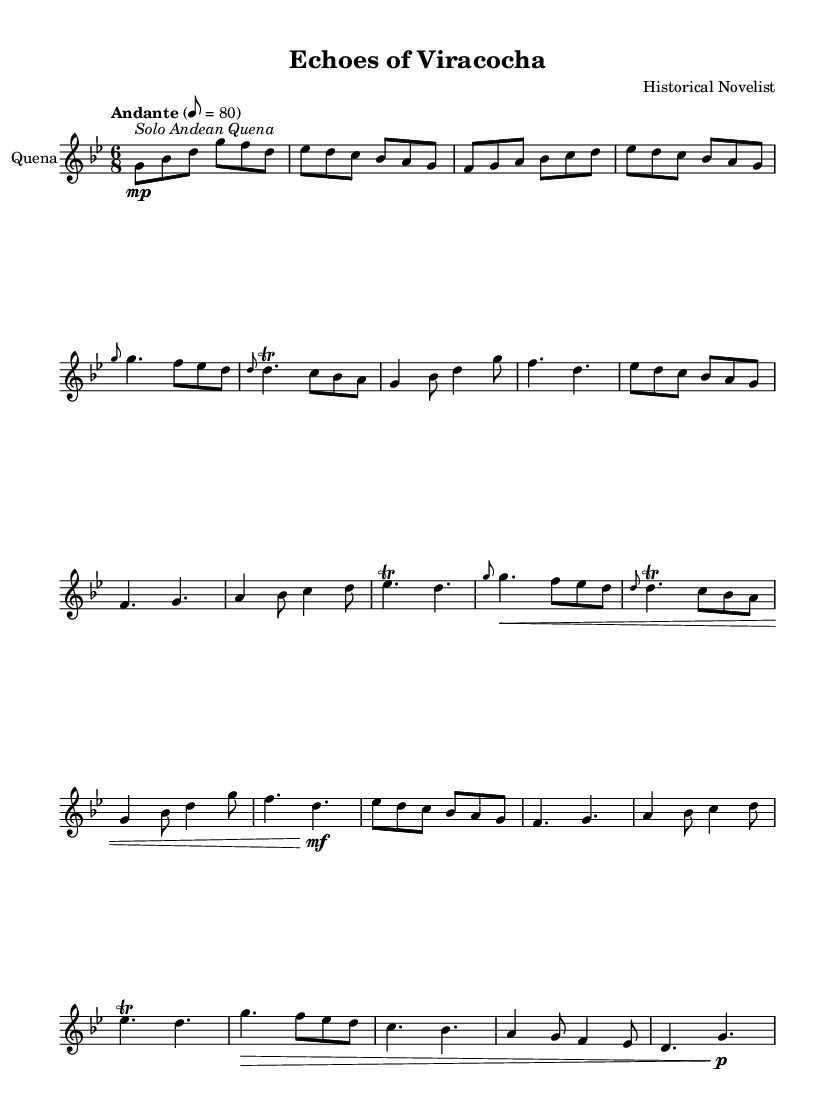What is the key signature of this music? The key signature is G minor, which is indicated by two flats (B-flat and E-flat). This can be determined by looking at the key signature at the beginning of the staff.
Answer: G minor What is the time signature of the piece? The time signature is 6/8, which is displayed at the beginning of the music. It indicates that there are six eighth notes per measure.
Answer: 6/8 What is the tempo marking of this piece? The tempo marking is "Andante", which suggests a moderate tempo. In the score, the tempo is indicated after the key and time signature, along with a metronome marking of 80 beats per minute.
Answer: Andante How many themes are present in the music? There are two distinct themes labeled as Theme A and Theme B, identifiable by their structure and melodic content. These themes are indicated in the score.
Answer: Two What is the dynamic marking for the first coda section? The dynamic marking for the first coda section is a crescendo followed by a piano marking on the last note. This indicates that the volume should increase and then soften.
Answer: Crescendo and piano What instrument is indicated in the score? The instrument indicated in the score is the Quena, which is mentioned at the beginning of the staff. This woodwind instrument is traditional in Andean music.
Answer: Quena What musical style does this piece represent? This piece represents Andean music, specifically inspired by Incan creation myths, which influences its melodic structure and cultural significance.
Answer: Andean music 